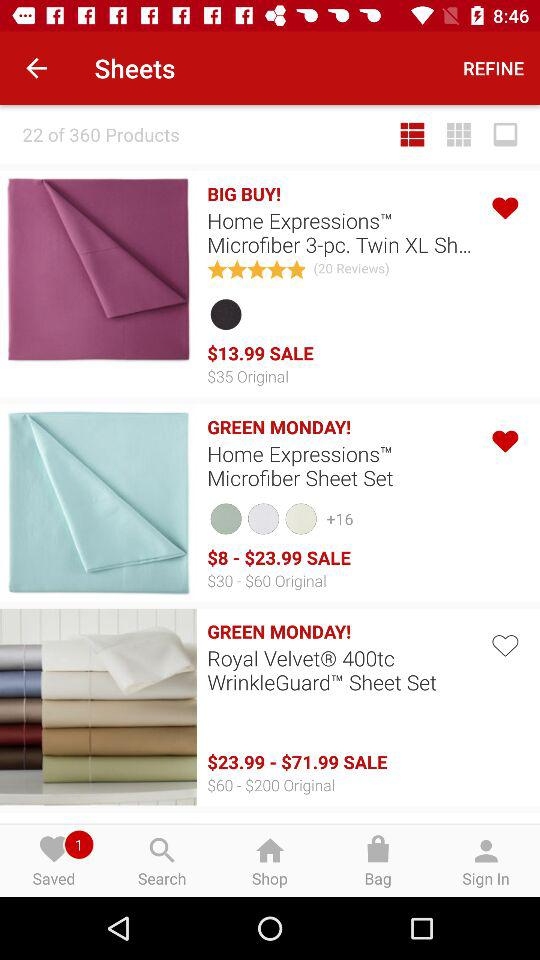What is the total number of products? The total number of products is 360. 